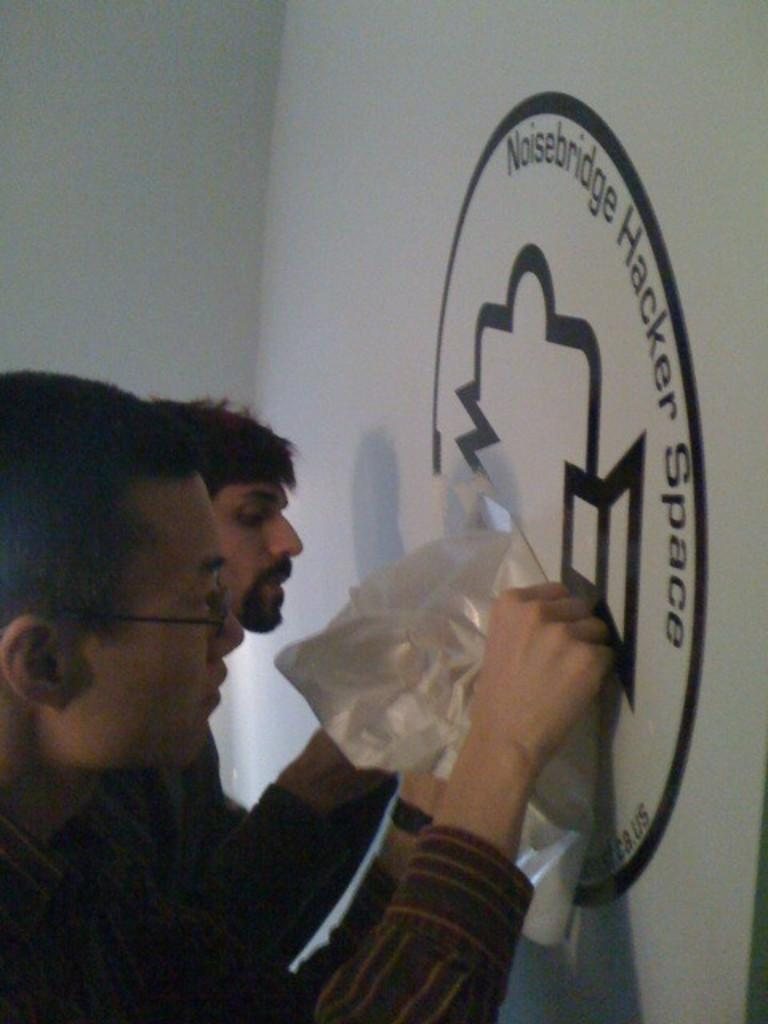How many people are present in the image? There are two people standing in the image. What are the people doing in the image? The people appear to be painting on a wall. What can be seen on the wall besides the painting? There is a logo on the wall. What is the color of the logo? The logo is white in color. Can you see a hole in the wall where the people are painting? There is no mention of a hole in the wall in the provided facts, so we cannot determine if one is present. 